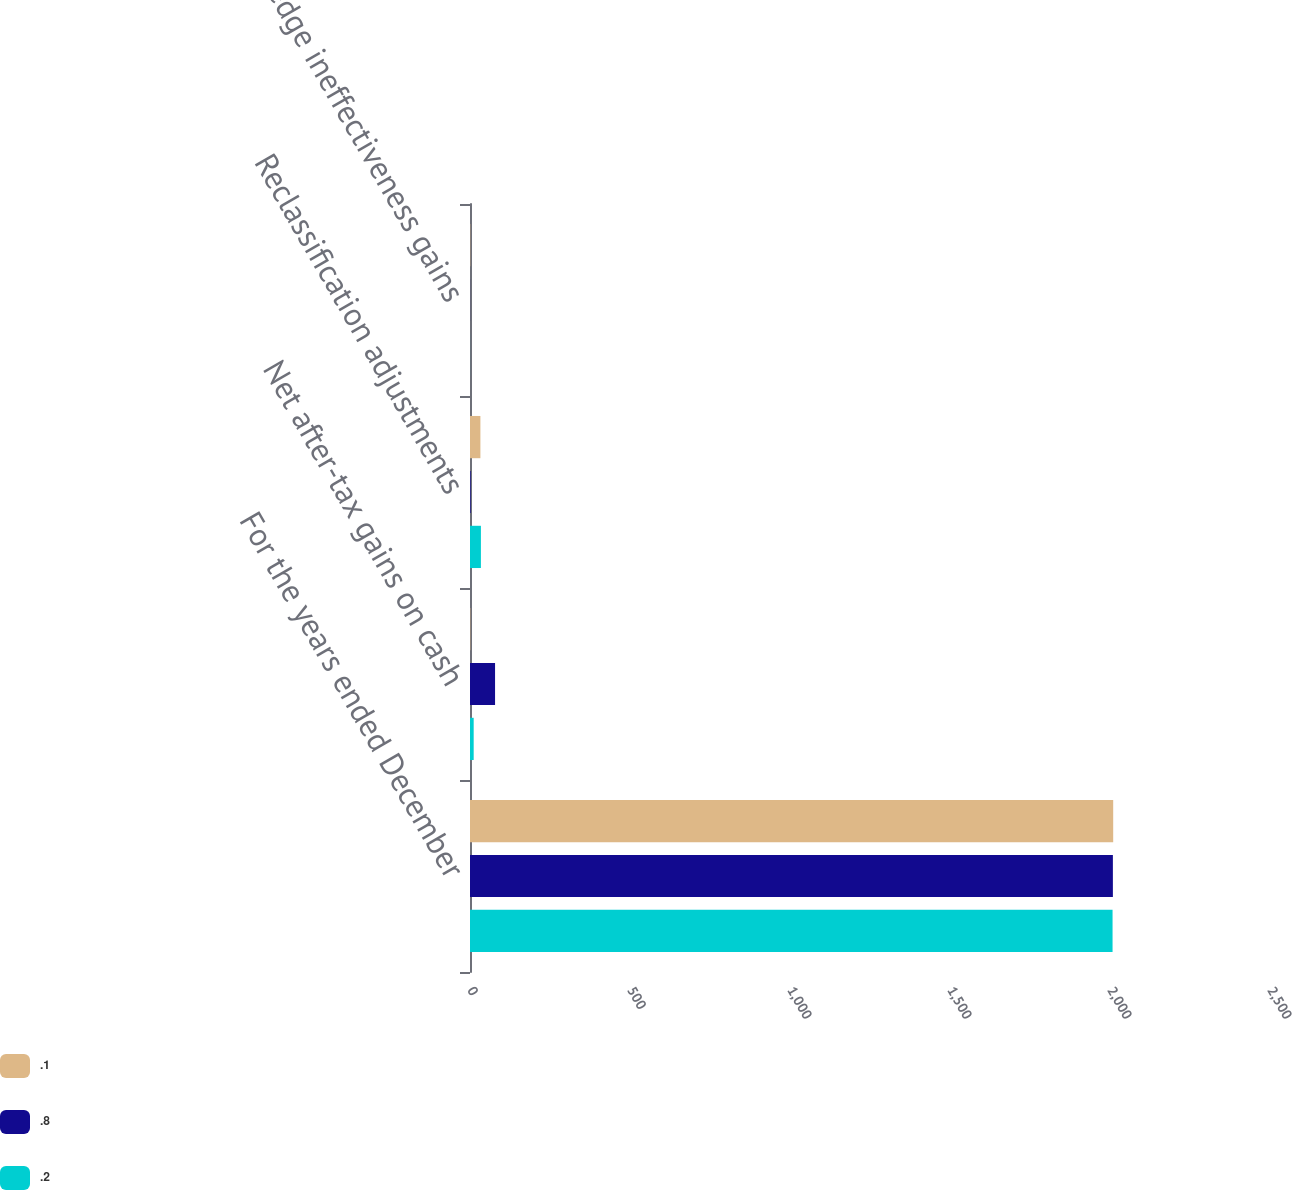Convert chart to OTSL. <chart><loc_0><loc_0><loc_500><loc_500><stacked_bar_chart><ecel><fcel>For the years ended December<fcel>Net after-tax gains on cash<fcel>Reclassification adjustments<fcel>Hedge ineffectiveness gains<nl><fcel>0.1<fcel>2010<fcel>1<fcel>32.5<fcel>0.8<nl><fcel>0.8<fcel>2009<fcel>78.3<fcel>1.9<fcel>0.2<nl><fcel>0.2<fcel>2008<fcel>11.5<fcel>34.1<fcel>0.1<nl></chart> 